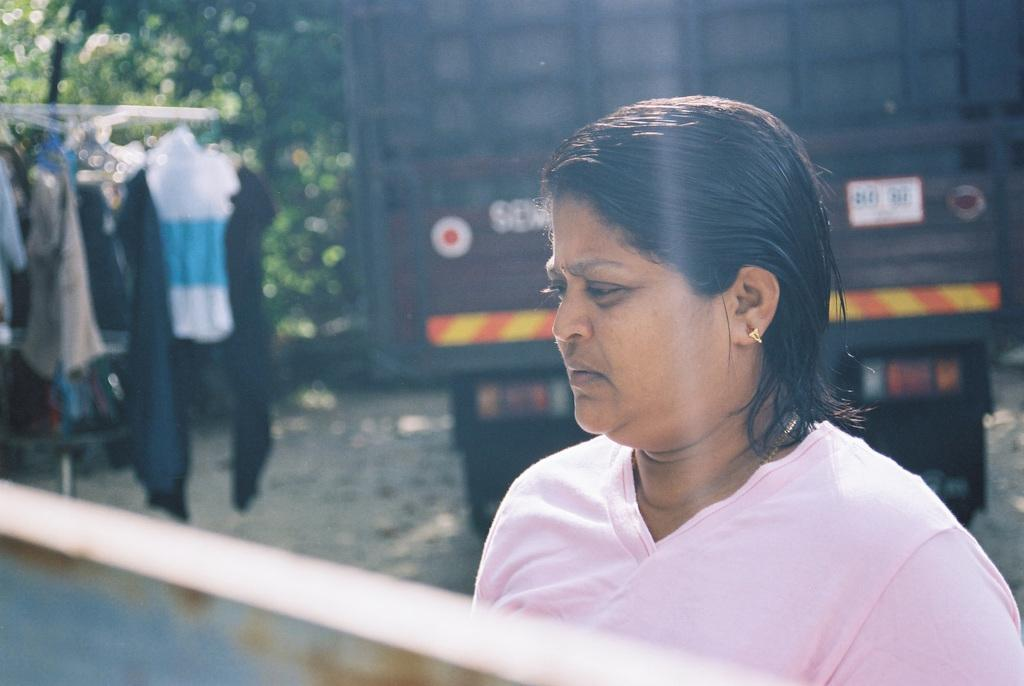What is the main subject of the image? There is a woman standing in the center of the image. What is in front of the woman? There is an object in front of the woman. What can be seen in the background of the image? There are trees, hangers, clothes, and a vehicle in the background of the image. What type of rhythm can be heard coming from the celery in the image? There is no celery present in the image, so it's not possible to determine any rhythm associated with it. 